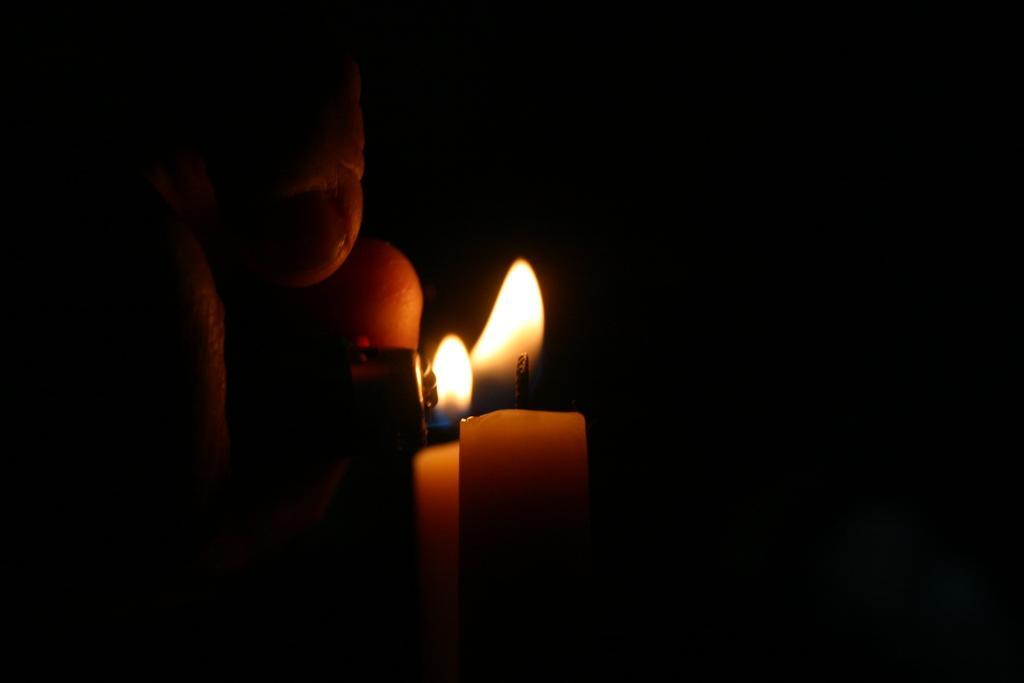Could you give a brief overview of what you see in this image? In this picture we can see a person's hand, a lighter and a candle, we can see a dark background. 